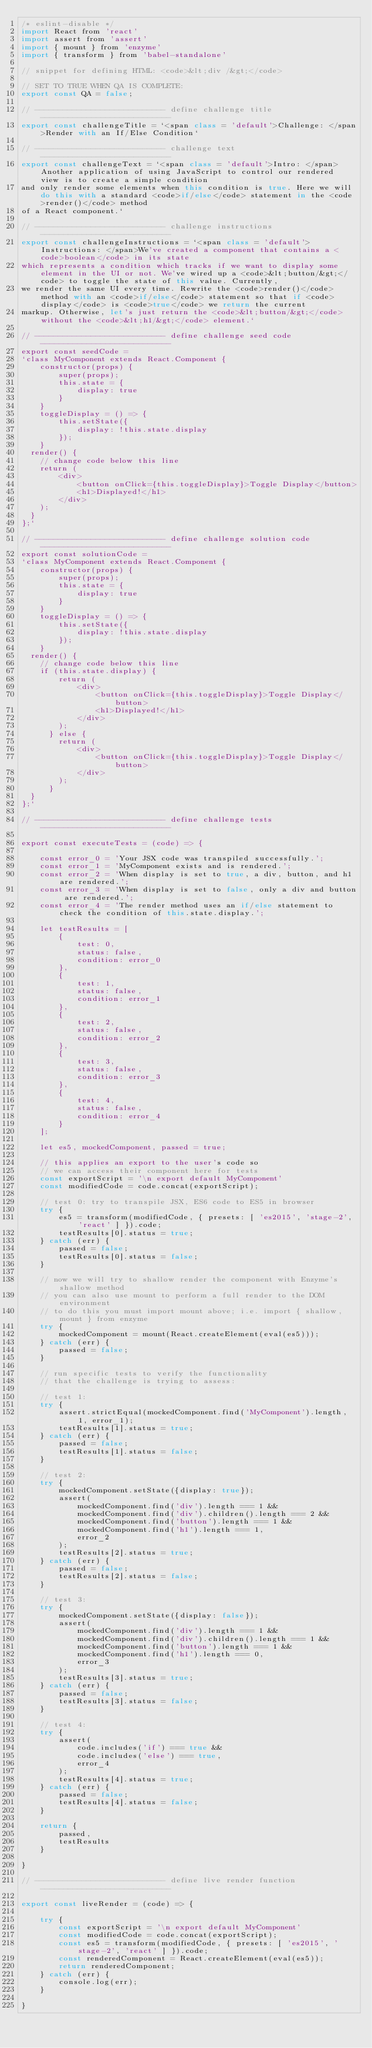Convert code to text. <code><loc_0><loc_0><loc_500><loc_500><_JavaScript_>/* eslint-disable */
import React from 'react'
import assert from 'assert'
import { mount } from 'enzyme'
import { transform } from 'babel-standalone'

// snippet for defining HTML: <code>&lt;div /&gt;</code>

// SET TO TRUE WHEN QA IS COMPLETE:
export const QA = false;

// ---------------------------- define challenge title ----------------------------
export const challengeTitle = `<span class = 'default'>Challenge: </span>Render with an If/Else Condition`

// ---------------------------- challenge text ----------------------------
export const challengeText = `<span class = 'default'>Intro: </span>Another application of using JavaScript to control our rendered view is to create a simple condition
and only render some elements when this condition is true. Here we will do this with a standard <code>if/else</code> statement in the <code>render()</code> method
of a React component.`

// ---------------------------- challenge instructions ----------------------------
export const challengeInstructions = `<span class = 'default'>Instructions: </span>We've created a component that contains a <code>boolean</code> in its state
which represents a condition which tracks if we want to display some element in the UI or not. We've wired up a <code>&lt;button/&gt;</code> to toggle the state of this value. Currently,
we render the same UI every time. Rewrite the <code>render()</code> method with an <code>if/else</code> statement so that if <code>display</code> is <code>true</code> we return the current
markup. Otherwise, let's just return the <code>&lt;button/&gt;</code> without the <code>&lt;h1/&gt;</code> element.`

// ---------------------------- define challenge seed code ----------------------------
export const seedCode =
`class MyComponent extends React.Component {
	constructor(props) {
		super(props);
		this.state = {
			display: true
		}
	}
	toggleDisplay = () => {
		this.setState({
			display: !this.state.display
		});
	}
  render() {
  	// change code below this line
    return (
	   	<div>
	   		<button onClick={this.toggleDisplay}>Toggle Display</button>
	   		<h1>Displayed!</h1>
	   	</div>
    );
  }
};`

// ---------------------------- define challenge solution code ----------------------------
export const solutionCode =
`class MyComponent extends React.Component {
	constructor(props) {
		super(props);
		this.state = {
			display: true
		}
	}
	toggleDisplay = () => {
		this.setState({
			display: !this.state.display
		});
	}
  render() {
  	// change code below this line
  	if (this.state.display) {
	    return (
		   	<div>
		   		<button onClick={this.toggleDisplay}>Toggle Display</button>
		   		<h1>Displayed!</h1>
		   	</div>
	    );
	  } else {
	  	return (
	  		<div>
		   		<button onClick={this.toggleDisplay}>Toggle Display</button>
		   	</div>
	  	);
	  }
  }
};`

// ---------------------------- define challenge tests ----------------------------

export const executeTests = (code) => {

	const error_0 = 'Your JSX code was transpiled successfully.';
	const error_1 = 'MyComponent exists and is rendered.';
	const error_2 = 'When display is set to true, a div, button, and h1 are rendered.';
	const error_3 = 'When display is set to false, only a div and button are rendered.';
	const error_4 = 'The render method uses an if/else statement to check the condition of this.state.display.';

	let testResults = [
		{
			test: 0,
			status: false,
			condition: error_0
		},
		{
			test: 1,
			status: false,
			condition: error_1
		},
		{
			test: 2,
			status: false,
			condition: error_2
		},
		{
			test: 3,
			status: false,
			condition: error_3
		},
		{
			test: 4,
			status: false,
			condition: error_4
		}
	];

	let es5, mockedComponent, passed = true;

	// this applies an export to the user's code so
	// we can access their component here for tests
	const exportScript = '\n export default MyComponent'
	const modifiedCode = code.concat(exportScript);
	
	// test 0: try to transpile JSX, ES6 code to ES5 in browser
	try {
		es5 = transform(modifiedCode, { presets: [ 'es2015', 'stage-2', 'react' ] }).code;
		testResults[0].status = true;
	} catch (err) {
		passed = false;
		testResults[0].status = false;
	}
	
	// now we will try to shallow render the component with Enzyme's shallow method
	// you can also use mount to perform a full render to the DOM environment
	// to do this you must import mount above; i.e. import { shallow, mount } from enzyme
	try {
		mockedComponent = mount(React.createElement(eval(es5)));
	} catch (err) {
		passed = false;
	}

	// run specific tests to verify the functionality
	// that the challenge is trying to assess:

	// test 1:
	try {
		assert.strictEqual(mockedComponent.find('MyComponent').length, 1, error_1);
		testResults[1].status = true;
	} catch (err) {
		passed = false;
		testResults[1].status = false;
	}

	// test 2:
	try {
		mockedComponent.setState({display: true});
		assert(
			mockedComponent.find('div').length === 1 &&
			mockedComponent.find('div').children().length === 2 &&
			mockedComponent.find('button').length === 1 &&
			mockedComponent.find('h1').length === 1,
			error_2
		);
		testResults[2].status = true;
	} catch (err) {
		passed = false;
		testResults[2].status = false;		
	}

	// test 3:
	try {
		mockedComponent.setState({display: false});
		assert(
			mockedComponent.find('div').length === 1 &&
			mockedComponent.find('div').children().length === 1 &&
			mockedComponent.find('button').length === 1 &&
			mockedComponent.find('h1').length === 0,
			error_3
		);
		testResults[3].status = true;
	} catch (err) {
		passed = false;
		testResults[3].status = false;
	}

	// test 4:
	try {
		assert(
			code.includes('if') === true &&
			code.includes('else') === true,
			error_4
		);
		testResults[4].status = true;
	} catch (err) {
		passed = false;
		testResults[4].status = false;
	}

	return {
		passed,
		testResults
	}
	
}

// ---------------------------- define live render function ----------------------------

export const liveRender = (code) => {

	try {
		const exportScript = '\n export default MyComponent'
		const modifiedCode = code.concat(exportScript);
		const es5 = transform(modifiedCode, { presets: [ 'es2015', 'stage-2', 'react' ] }).code;
		const renderedComponent = React.createElement(eval(es5));
		return renderedComponent;
	} catch (err) {
		console.log(err);
	}

}</code> 